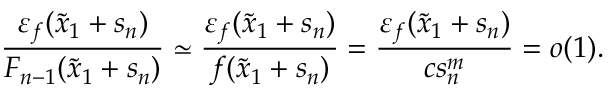Convert formula to latex. <formula><loc_0><loc_0><loc_500><loc_500>\frac { \varepsilon _ { f } ( \widetilde { x } _ { 1 } + s _ { n } ) } { F _ { n - 1 } ( \widetilde { x } _ { 1 } + s _ { n } ) } \simeq \frac { \varepsilon _ { f } ( \widetilde { x } _ { 1 } + s _ { n } ) } { f ( \widetilde { x } _ { 1 } + s _ { n } ) } = \frac { \varepsilon _ { f } ( \widetilde { x } _ { 1 } + s _ { n } ) } { c s _ { n } ^ { m } } = o ( 1 ) .</formula> 